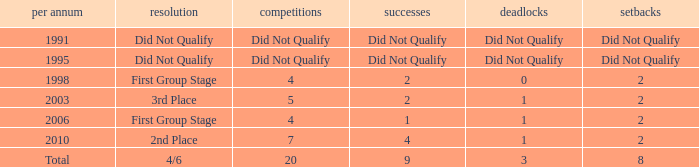What were the matches where the teams finished in the first group stage, in 1998? 4.0. 